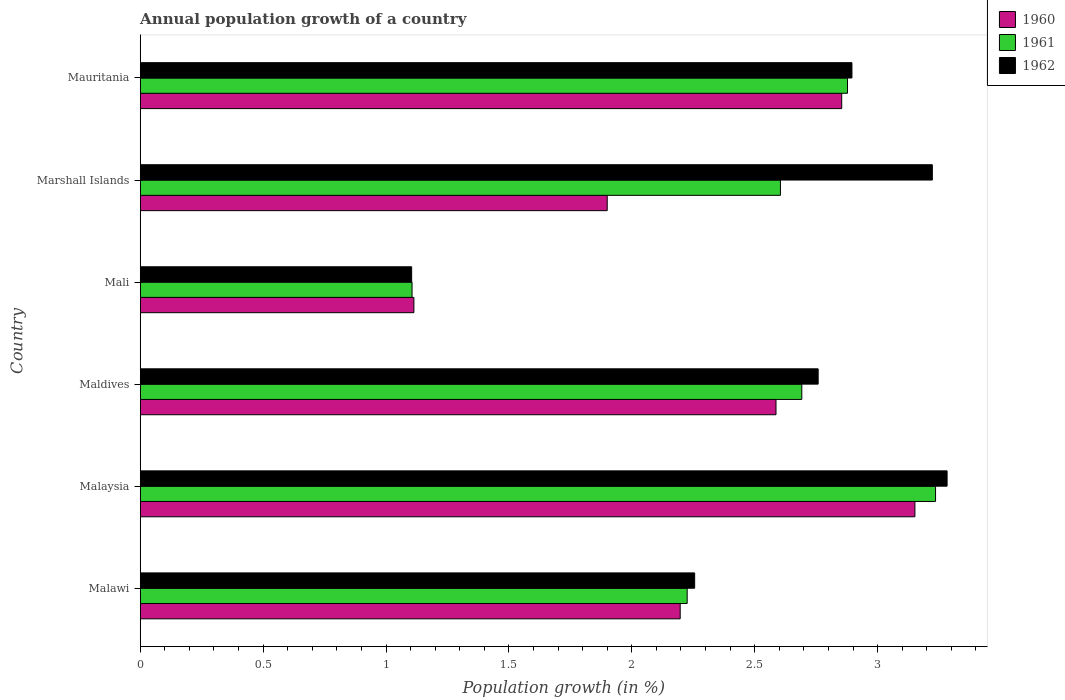How many different coloured bars are there?
Keep it short and to the point. 3. Are the number of bars per tick equal to the number of legend labels?
Provide a succinct answer. Yes. Are the number of bars on each tick of the Y-axis equal?
Offer a very short reply. Yes. What is the label of the 6th group of bars from the top?
Offer a very short reply. Malawi. What is the annual population growth in 1961 in Marshall Islands?
Provide a succinct answer. 2.6. Across all countries, what is the maximum annual population growth in 1961?
Provide a succinct answer. 3.24. Across all countries, what is the minimum annual population growth in 1961?
Your answer should be compact. 1.11. In which country was the annual population growth in 1962 maximum?
Ensure brevity in your answer.  Malaysia. In which country was the annual population growth in 1961 minimum?
Ensure brevity in your answer.  Mali. What is the total annual population growth in 1961 in the graph?
Your answer should be compact. 14.74. What is the difference between the annual population growth in 1960 in Malawi and that in Maldives?
Your response must be concise. -0.39. What is the difference between the annual population growth in 1960 in Malaysia and the annual population growth in 1962 in Mali?
Provide a succinct answer. 2.05. What is the average annual population growth in 1962 per country?
Make the answer very short. 2.59. What is the difference between the annual population growth in 1962 and annual population growth in 1960 in Mali?
Keep it short and to the point. -0.01. What is the ratio of the annual population growth in 1961 in Malaysia to that in Marshall Islands?
Your answer should be compact. 1.24. Is the annual population growth in 1962 in Malawi less than that in Mali?
Give a very brief answer. No. What is the difference between the highest and the second highest annual population growth in 1960?
Ensure brevity in your answer.  0.3. What is the difference between the highest and the lowest annual population growth in 1961?
Your answer should be compact. 2.13. In how many countries, is the annual population growth in 1960 greater than the average annual population growth in 1960 taken over all countries?
Provide a succinct answer. 3. What does the 2nd bar from the top in Mali represents?
Keep it short and to the point. 1961. How many countries are there in the graph?
Your answer should be compact. 6. What is the difference between two consecutive major ticks on the X-axis?
Your answer should be very brief. 0.5. Does the graph contain grids?
Make the answer very short. No. Where does the legend appear in the graph?
Ensure brevity in your answer.  Top right. What is the title of the graph?
Give a very brief answer. Annual population growth of a country. Does "1978" appear as one of the legend labels in the graph?
Provide a succinct answer. No. What is the label or title of the X-axis?
Offer a very short reply. Population growth (in %). What is the label or title of the Y-axis?
Your response must be concise. Country. What is the Population growth (in %) of 1960 in Malawi?
Provide a succinct answer. 2.2. What is the Population growth (in %) of 1961 in Malawi?
Your answer should be compact. 2.23. What is the Population growth (in %) in 1962 in Malawi?
Ensure brevity in your answer.  2.26. What is the Population growth (in %) of 1960 in Malaysia?
Your answer should be compact. 3.15. What is the Population growth (in %) of 1961 in Malaysia?
Make the answer very short. 3.24. What is the Population growth (in %) of 1962 in Malaysia?
Keep it short and to the point. 3.28. What is the Population growth (in %) of 1960 in Maldives?
Your answer should be compact. 2.59. What is the Population growth (in %) in 1961 in Maldives?
Offer a terse response. 2.69. What is the Population growth (in %) of 1962 in Maldives?
Provide a short and direct response. 2.76. What is the Population growth (in %) of 1960 in Mali?
Give a very brief answer. 1.11. What is the Population growth (in %) of 1961 in Mali?
Ensure brevity in your answer.  1.11. What is the Population growth (in %) of 1962 in Mali?
Ensure brevity in your answer.  1.1. What is the Population growth (in %) of 1960 in Marshall Islands?
Make the answer very short. 1.9. What is the Population growth (in %) of 1961 in Marshall Islands?
Keep it short and to the point. 2.6. What is the Population growth (in %) in 1962 in Marshall Islands?
Make the answer very short. 3.22. What is the Population growth (in %) in 1960 in Mauritania?
Make the answer very short. 2.85. What is the Population growth (in %) of 1961 in Mauritania?
Your answer should be compact. 2.88. What is the Population growth (in %) of 1962 in Mauritania?
Provide a short and direct response. 2.9. Across all countries, what is the maximum Population growth (in %) in 1960?
Make the answer very short. 3.15. Across all countries, what is the maximum Population growth (in %) in 1961?
Your answer should be compact. 3.24. Across all countries, what is the maximum Population growth (in %) in 1962?
Provide a succinct answer. 3.28. Across all countries, what is the minimum Population growth (in %) of 1960?
Your response must be concise. 1.11. Across all countries, what is the minimum Population growth (in %) in 1961?
Keep it short and to the point. 1.11. Across all countries, what is the minimum Population growth (in %) of 1962?
Give a very brief answer. 1.1. What is the total Population growth (in %) in 1960 in the graph?
Give a very brief answer. 13.8. What is the total Population growth (in %) in 1961 in the graph?
Your response must be concise. 14.74. What is the total Population growth (in %) of 1962 in the graph?
Give a very brief answer. 15.52. What is the difference between the Population growth (in %) of 1960 in Malawi and that in Malaysia?
Give a very brief answer. -0.95. What is the difference between the Population growth (in %) of 1961 in Malawi and that in Malaysia?
Keep it short and to the point. -1.01. What is the difference between the Population growth (in %) in 1962 in Malawi and that in Malaysia?
Provide a succinct answer. -1.03. What is the difference between the Population growth (in %) of 1960 in Malawi and that in Maldives?
Offer a very short reply. -0.39. What is the difference between the Population growth (in %) of 1961 in Malawi and that in Maldives?
Your answer should be very brief. -0.47. What is the difference between the Population growth (in %) in 1962 in Malawi and that in Maldives?
Your response must be concise. -0.5. What is the difference between the Population growth (in %) in 1960 in Malawi and that in Mali?
Give a very brief answer. 1.08. What is the difference between the Population growth (in %) of 1961 in Malawi and that in Mali?
Offer a terse response. 1.12. What is the difference between the Population growth (in %) in 1962 in Malawi and that in Mali?
Give a very brief answer. 1.15. What is the difference between the Population growth (in %) of 1960 in Malawi and that in Marshall Islands?
Your response must be concise. 0.3. What is the difference between the Population growth (in %) of 1961 in Malawi and that in Marshall Islands?
Offer a very short reply. -0.38. What is the difference between the Population growth (in %) of 1962 in Malawi and that in Marshall Islands?
Keep it short and to the point. -0.97. What is the difference between the Population growth (in %) in 1960 in Malawi and that in Mauritania?
Your answer should be compact. -0.66. What is the difference between the Population growth (in %) in 1961 in Malawi and that in Mauritania?
Offer a very short reply. -0.65. What is the difference between the Population growth (in %) of 1962 in Malawi and that in Mauritania?
Your answer should be very brief. -0.64. What is the difference between the Population growth (in %) in 1960 in Malaysia and that in Maldives?
Offer a terse response. 0.57. What is the difference between the Population growth (in %) of 1961 in Malaysia and that in Maldives?
Your answer should be compact. 0.54. What is the difference between the Population growth (in %) of 1962 in Malaysia and that in Maldives?
Provide a short and direct response. 0.52. What is the difference between the Population growth (in %) of 1960 in Malaysia and that in Mali?
Provide a succinct answer. 2.04. What is the difference between the Population growth (in %) of 1961 in Malaysia and that in Mali?
Provide a succinct answer. 2.13. What is the difference between the Population growth (in %) of 1962 in Malaysia and that in Mali?
Keep it short and to the point. 2.18. What is the difference between the Population growth (in %) of 1960 in Malaysia and that in Marshall Islands?
Offer a very short reply. 1.25. What is the difference between the Population growth (in %) in 1961 in Malaysia and that in Marshall Islands?
Your response must be concise. 0.63. What is the difference between the Population growth (in %) in 1960 in Malaysia and that in Mauritania?
Your response must be concise. 0.3. What is the difference between the Population growth (in %) of 1961 in Malaysia and that in Mauritania?
Ensure brevity in your answer.  0.36. What is the difference between the Population growth (in %) of 1962 in Malaysia and that in Mauritania?
Make the answer very short. 0.39. What is the difference between the Population growth (in %) in 1960 in Maldives and that in Mali?
Keep it short and to the point. 1.47. What is the difference between the Population growth (in %) of 1961 in Maldives and that in Mali?
Provide a short and direct response. 1.59. What is the difference between the Population growth (in %) of 1962 in Maldives and that in Mali?
Ensure brevity in your answer.  1.65. What is the difference between the Population growth (in %) of 1960 in Maldives and that in Marshall Islands?
Provide a succinct answer. 0.69. What is the difference between the Population growth (in %) in 1961 in Maldives and that in Marshall Islands?
Keep it short and to the point. 0.09. What is the difference between the Population growth (in %) in 1962 in Maldives and that in Marshall Islands?
Offer a very short reply. -0.46. What is the difference between the Population growth (in %) of 1960 in Maldives and that in Mauritania?
Your response must be concise. -0.27. What is the difference between the Population growth (in %) in 1961 in Maldives and that in Mauritania?
Your response must be concise. -0.19. What is the difference between the Population growth (in %) of 1962 in Maldives and that in Mauritania?
Provide a succinct answer. -0.14. What is the difference between the Population growth (in %) of 1960 in Mali and that in Marshall Islands?
Provide a short and direct response. -0.79. What is the difference between the Population growth (in %) of 1961 in Mali and that in Marshall Islands?
Your answer should be very brief. -1.5. What is the difference between the Population growth (in %) in 1962 in Mali and that in Marshall Islands?
Offer a very short reply. -2.12. What is the difference between the Population growth (in %) in 1960 in Mali and that in Mauritania?
Keep it short and to the point. -1.74. What is the difference between the Population growth (in %) of 1961 in Mali and that in Mauritania?
Offer a very short reply. -1.77. What is the difference between the Population growth (in %) in 1962 in Mali and that in Mauritania?
Provide a succinct answer. -1.79. What is the difference between the Population growth (in %) in 1960 in Marshall Islands and that in Mauritania?
Provide a succinct answer. -0.95. What is the difference between the Population growth (in %) in 1961 in Marshall Islands and that in Mauritania?
Give a very brief answer. -0.27. What is the difference between the Population growth (in %) of 1962 in Marshall Islands and that in Mauritania?
Your answer should be compact. 0.33. What is the difference between the Population growth (in %) in 1960 in Malawi and the Population growth (in %) in 1961 in Malaysia?
Your answer should be compact. -1.04. What is the difference between the Population growth (in %) in 1960 in Malawi and the Population growth (in %) in 1962 in Malaysia?
Offer a very short reply. -1.09. What is the difference between the Population growth (in %) of 1961 in Malawi and the Population growth (in %) of 1962 in Malaysia?
Provide a succinct answer. -1.06. What is the difference between the Population growth (in %) of 1960 in Malawi and the Population growth (in %) of 1961 in Maldives?
Make the answer very short. -0.49. What is the difference between the Population growth (in %) in 1960 in Malawi and the Population growth (in %) in 1962 in Maldives?
Ensure brevity in your answer.  -0.56. What is the difference between the Population growth (in %) in 1961 in Malawi and the Population growth (in %) in 1962 in Maldives?
Your answer should be compact. -0.53. What is the difference between the Population growth (in %) in 1960 in Malawi and the Population growth (in %) in 1961 in Mali?
Keep it short and to the point. 1.09. What is the difference between the Population growth (in %) in 1960 in Malawi and the Population growth (in %) in 1962 in Mali?
Offer a very short reply. 1.09. What is the difference between the Population growth (in %) of 1961 in Malawi and the Population growth (in %) of 1962 in Mali?
Your response must be concise. 1.12. What is the difference between the Population growth (in %) of 1960 in Malawi and the Population growth (in %) of 1961 in Marshall Islands?
Give a very brief answer. -0.41. What is the difference between the Population growth (in %) of 1960 in Malawi and the Population growth (in %) of 1962 in Marshall Islands?
Offer a very short reply. -1.03. What is the difference between the Population growth (in %) in 1961 in Malawi and the Population growth (in %) in 1962 in Marshall Islands?
Provide a succinct answer. -1. What is the difference between the Population growth (in %) in 1960 in Malawi and the Population growth (in %) in 1961 in Mauritania?
Provide a succinct answer. -0.68. What is the difference between the Population growth (in %) of 1960 in Malawi and the Population growth (in %) of 1962 in Mauritania?
Offer a terse response. -0.7. What is the difference between the Population growth (in %) in 1961 in Malawi and the Population growth (in %) in 1962 in Mauritania?
Provide a short and direct response. -0.67. What is the difference between the Population growth (in %) in 1960 in Malaysia and the Population growth (in %) in 1961 in Maldives?
Offer a very short reply. 0.46. What is the difference between the Population growth (in %) of 1960 in Malaysia and the Population growth (in %) of 1962 in Maldives?
Your response must be concise. 0.39. What is the difference between the Population growth (in %) of 1961 in Malaysia and the Population growth (in %) of 1962 in Maldives?
Your answer should be very brief. 0.48. What is the difference between the Population growth (in %) in 1960 in Malaysia and the Population growth (in %) in 1961 in Mali?
Offer a terse response. 2.05. What is the difference between the Population growth (in %) in 1960 in Malaysia and the Population growth (in %) in 1962 in Mali?
Keep it short and to the point. 2.05. What is the difference between the Population growth (in %) in 1961 in Malaysia and the Population growth (in %) in 1962 in Mali?
Your answer should be compact. 2.13. What is the difference between the Population growth (in %) of 1960 in Malaysia and the Population growth (in %) of 1961 in Marshall Islands?
Your answer should be very brief. 0.55. What is the difference between the Population growth (in %) of 1960 in Malaysia and the Population growth (in %) of 1962 in Marshall Islands?
Make the answer very short. -0.07. What is the difference between the Population growth (in %) of 1961 in Malaysia and the Population growth (in %) of 1962 in Marshall Islands?
Offer a very short reply. 0.01. What is the difference between the Population growth (in %) of 1960 in Malaysia and the Population growth (in %) of 1961 in Mauritania?
Provide a succinct answer. 0.27. What is the difference between the Population growth (in %) of 1960 in Malaysia and the Population growth (in %) of 1962 in Mauritania?
Your answer should be very brief. 0.26. What is the difference between the Population growth (in %) of 1961 in Malaysia and the Population growth (in %) of 1962 in Mauritania?
Your answer should be very brief. 0.34. What is the difference between the Population growth (in %) in 1960 in Maldives and the Population growth (in %) in 1961 in Mali?
Give a very brief answer. 1.48. What is the difference between the Population growth (in %) in 1960 in Maldives and the Population growth (in %) in 1962 in Mali?
Your response must be concise. 1.48. What is the difference between the Population growth (in %) in 1961 in Maldives and the Population growth (in %) in 1962 in Mali?
Make the answer very short. 1.59. What is the difference between the Population growth (in %) in 1960 in Maldives and the Population growth (in %) in 1961 in Marshall Islands?
Provide a short and direct response. -0.02. What is the difference between the Population growth (in %) of 1960 in Maldives and the Population growth (in %) of 1962 in Marshall Islands?
Provide a short and direct response. -0.64. What is the difference between the Population growth (in %) in 1961 in Maldives and the Population growth (in %) in 1962 in Marshall Islands?
Give a very brief answer. -0.53. What is the difference between the Population growth (in %) in 1960 in Maldives and the Population growth (in %) in 1961 in Mauritania?
Your response must be concise. -0.29. What is the difference between the Population growth (in %) of 1960 in Maldives and the Population growth (in %) of 1962 in Mauritania?
Offer a terse response. -0.31. What is the difference between the Population growth (in %) of 1961 in Maldives and the Population growth (in %) of 1962 in Mauritania?
Give a very brief answer. -0.2. What is the difference between the Population growth (in %) of 1960 in Mali and the Population growth (in %) of 1961 in Marshall Islands?
Provide a succinct answer. -1.49. What is the difference between the Population growth (in %) of 1960 in Mali and the Population growth (in %) of 1962 in Marshall Islands?
Make the answer very short. -2.11. What is the difference between the Population growth (in %) of 1961 in Mali and the Population growth (in %) of 1962 in Marshall Islands?
Offer a very short reply. -2.12. What is the difference between the Population growth (in %) in 1960 in Mali and the Population growth (in %) in 1961 in Mauritania?
Your answer should be very brief. -1.76. What is the difference between the Population growth (in %) in 1960 in Mali and the Population growth (in %) in 1962 in Mauritania?
Ensure brevity in your answer.  -1.78. What is the difference between the Population growth (in %) of 1961 in Mali and the Population growth (in %) of 1962 in Mauritania?
Make the answer very short. -1.79. What is the difference between the Population growth (in %) in 1960 in Marshall Islands and the Population growth (in %) in 1961 in Mauritania?
Give a very brief answer. -0.98. What is the difference between the Population growth (in %) of 1960 in Marshall Islands and the Population growth (in %) of 1962 in Mauritania?
Your answer should be very brief. -1. What is the difference between the Population growth (in %) of 1961 in Marshall Islands and the Population growth (in %) of 1962 in Mauritania?
Provide a short and direct response. -0.29. What is the average Population growth (in %) of 1960 per country?
Give a very brief answer. 2.3. What is the average Population growth (in %) in 1961 per country?
Give a very brief answer. 2.46. What is the average Population growth (in %) of 1962 per country?
Your answer should be very brief. 2.59. What is the difference between the Population growth (in %) in 1960 and Population growth (in %) in 1961 in Malawi?
Ensure brevity in your answer.  -0.03. What is the difference between the Population growth (in %) of 1960 and Population growth (in %) of 1962 in Malawi?
Offer a terse response. -0.06. What is the difference between the Population growth (in %) of 1961 and Population growth (in %) of 1962 in Malawi?
Offer a very short reply. -0.03. What is the difference between the Population growth (in %) in 1960 and Population growth (in %) in 1961 in Malaysia?
Make the answer very short. -0.08. What is the difference between the Population growth (in %) in 1960 and Population growth (in %) in 1962 in Malaysia?
Ensure brevity in your answer.  -0.13. What is the difference between the Population growth (in %) in 1961 and Population growth (in %) in 1962 in Malaysia?
Provide a short and direct response. -0.05. What is the difference between the Population growth (in %) of 1960 and Population growth (in %) of 1961 in Maldives?
Provide a short and direct response. -0.1. What is the difference between the Population growth (in %) in 1960 and Population growth (in %) in 1962 in Maldives?
Make the answer very short. -0.17. What is the difference between the Population growth (in %) in 1961 and Population growth (in %) in 1962 in Maldives?
Ensure brevity in your answer.  -0.07. What is the difference between the Population growth (in %) of 1960 and Population growth (in %) of 1961 in Mali?
Give a very brief answer. 0.01. What is the difference between the Population growth (in %) of 1960 and Population growth (in %) of 1962 in Mali?
Your answer should be very brief. 0.01. What is the difference between the Population growth (in %) of 1961 and Population growth (in %) of 1962 in Mali?
Provide a short and direct response. 0. What is the difference between the Population growth (in %) in 1960 and Population growth (in %) in 1961 in Marshall Islands?
Provide a short and direct response. -0.7. What is the difference between the Population growth (in %) of 1960 and Population growth (in %) of 1962 in Marshall Islands?
Give a very brief answer. -1.32. What is the difference between the Population growth (in %) in 1961 and Population growth (in %) in 1962 in Marshall Islands?
Your answer should be very brief. -0.62. What is the difference between the Population growth (in %) in 1960 and Population growth (in %) in 1961 in Mauritania?
Offer a terse response. -0.02. What is the difference between the Population growth (in %) in 1960 and Population growth (in %) in 1962 in Mauritania?
Make the answer very short. -0.04. What is the difference between the Population growth (in %) in 1961 and Population growth (in %) in 1962 in Mauritania?
Offer a terse response. -0.02. What is the ratio of the Population growth (in %) of 1960 in Malawi to that in Malaysia?
Your answer should be very brief. 0.7. What is the ratio of the Population growth (in %) in 1961 in Malawi to that in Malaysia?
Your response must be concise. 0.69. What is the ratio of the Population growth (in %) of 1962 in Malawi to that in Malaysia?
Your answer should be very brief. 0.69. What is the ratio of the Population growth (in %) of 1960 in Malawi to that in Maldives?
Provide a succinct answer. 0.85. What is the ratio of the Population growth (in %) of 1961 in Malawi to that in Maldives?
Your answer should be compact. 0.83. What is the ratio of the Population growth (in %) of 1962 in Malawi to that in Maldives?
Offer a terse response. 0.82. What is the ratio of the Population growth (in %) in 1960 in Malawi to that in Mali?
Provide a succinct answer. 1.97. What is the ratio of the Population growth (in %) of 1961 in Malawi to that in Mali?
Give a very brief answer. 2.01. What is the ratio of the Population growth (in %) of 1962 in Malawi to that in Mali?
Give a very brief answer. 2.04. What is the ratio of the Population growth (in %) in 1960 in Malawi to that in Marshall Islands?
Provide a short and direct response. 1.16. What is the ratio of the Population growth (in %) in 1961 in Malawi to that in Marshall Islands?
Your answer should be compact. 0.85. What is the ratio of the Population growth (in %) of 1962 in Malawi to that in Marshall Islands?
Provide a short and direct response. 0.7. What is the ratio of the Population growth (in %) in 1960 in Malawi to that in Mauritania?
Your answer should be very brief. 0.77. What is the ratio of the Population growth (in %) of 1961 in Malawi to that in Mauritania?
Provide a short and direct response. 0.77. What is the ratio of the Population growth (in %) in 1962 in Malawi to that in Mauritania?
Make the answer very short. 0.78. What is the ratio of the Population growth (in %) of 1960 in Malaysia to that in Maldives?
Ensure brevity in your answer.  1.22. What is the ratio of the Population growth (in %) in 1961 in Malaysia to that in Maldives?
Your response must be concise. 1.2. What is the ratio of the Population growth (in %) of 1962 in Malaysia to that in Maldives?
Offer a terse response. 1.19. What is the ratio of the Population growth (in %) in 1960 in Malaysia to that in Mali?
Provide a succinct answer. 2.83. What is the ratio of the Population growth (in %) of 1961 in Malaysia to that in Mali?
Make the answer very short. 2.93. What is the ratio of the Population growth (in %) of 1962 in Malaysia to that in Mali?
Make the answer very short. 2.97. What is the ratio of the Population growth (in %) of 1960 in Malaysia to that in Marshall Islands?
Ensure brevity in your answer.  1.66. What is the ratio of the Population growth (in %) of 1961 in Malaysia to that in Marshall Islands?
Offer a terse response. 1.24. What is the ratio of the Population growth (in %) in 1962 in Malaysia to that in Marshall Islands?
Keep it short and to the point. 1.02. What is the ratio of the Population growth (in %) of 1960 in Malaysia to that in Mauritania?
Offer a terse response. 1.1. What is the ratio of the Population growth (in %) in 1961 in Malaysia to that in Mauritania?
Make the answer very short. 1.12. What is the ratio of the Population growth (in %) of 1962 in Malaysia to that in Mauritania?
Give a very brief answer. 1.13. What is the ratio of the Population growth (in %) in 1960 in Maldives to that in Mali?
Keep it short and to the point. 2.32. What is the ratio of the Population growth (in %) in 1961 in Maldives to that in Mali?
Your answer should be compact. 2.43. What is the ratio of the Population growth (in %) in 1962 in Maldives to that in Mali?
Offer a very short reply. 2.5. What is the ratio of the Population growth (in %) in 1960 in Maldives to that in Marshall Islands?
Keep it short and to the point. 1.36. What is the ratio of the Population growth (in %) of 1961 in Maldives to that in Marshall Islands?
Your answer should be compact. 1.03. What is the ratio of the Population growth (in %) of 1962 in Maldives to that in Marshall Islands?
Your answer should be very brief. 0.86. What is the ratio of the Population growth (in %) of 1960 in Maldives to that in Mauritania?
Make the answer very short. 0.91. What is the ratio of the Population growth (in %) of 1961 in Maldives to that in Mauritania?
Give a very brief answer. 0.94. What is the ratio of the Population growth (in %) in 1962 in Maldives to that in Mauritania?
Your response must be concise. 0.95. What is the ratio of the Population growth (in %) of 1960 in Mali to that in Marshall Islands?
Keep it short and to the point. 0.59. What is the ratio of the Population growth (in %) of 1961 in Mali to that in Marshall Islands?
Ensure brevity in your answer.  0.42. What is the ratio of the Population growth (in %) in 1962 in Mali to that in Marshall Islands?
Keep it short and to the point. 0.34. What is the ratio of the Population growth (in %) in 1960 in Mali to that in Mauritania?
Provide a short and direct response. 0.39. What is the ratio of the Population growth (in %) of 1961 in Mali to that in Mauritania?
Ensure brevity in your answer.  0.38. What is the ratio of the Population growth (in %) of 1962 in Mali to that in Mauritania?
Ensure brevity in your answer.  0.38. What is the ratio of the Population growth (in %) of 1960 in Marshall Islands to that in Mauritania?
Your answer should be very brief. 0.67. What is the ratio of the Population growth (in %) in 1961 in Marshall Islands to that in Mauritania?
Offer a very short reply. 0.91. What is the ratio of the Population growth (in %) of 1962 in Marshall Islands to that in Mauritania?
Make the answer very short. 1.11. What is the difference between the highest and the second highest Population growth (in %) of 1960?
Ensure brevity in your answer.  0.3. What is the difference between the highest and the second highest Population growth (in %) of 1961?
Provide a succinct answer. 0.36. What is the difference between the highest and the second highest Population growth (in %) of 1962?
Keep it short and to the point. 0.06. What is the difference between the highest and the lowest Population growth (in %) in 1960?
Ensure brevity in your answer.  2.04. What is the difference between the highest and the lowest Population growth (in %) of 1961?
Your answer should be very brief. 2.13. What is the difference between the highest and the lowest Population growth (in %) in 1962?
Give a very brief answer. 2.18. 